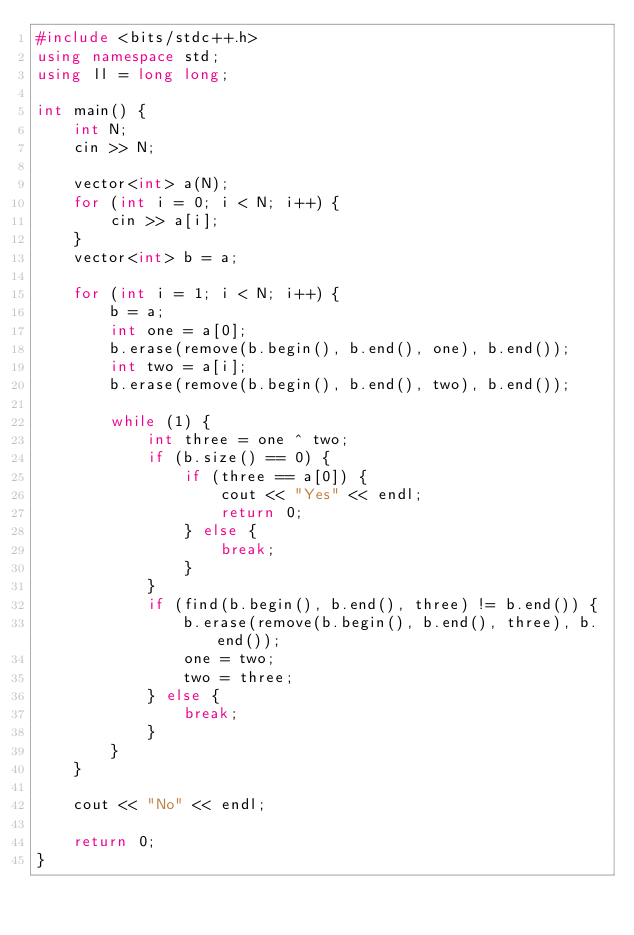<code> <loc_0><loc_0><loc_500><loc_500><_C++_>#include <bits/stdc++.h>
using namespace std;
using ll = long long;

int main() {
    int N;
    cin >> N;

    vector<int> a(N);
    for (int i = 0; i < N; i++) {
        cin >> a[i];
    }
    vector<int> b = a;

    for (int i = 1; i < N; i++) {
        b = a;
        int one = a[0];
        b.erase(remove(b.begin(), b.end(), one), b.end());
        int two = a[i];
        b.erase(remove(b.begin(), b.end(), two), b.end());

        while (1) {
            int three = one ^ two;
            if (b.size() == 0) {
                if (three == a[0]) {
                    cout << "Yes" << endl;
                    return 0;
                } else {
                    break;
                }
            }
            if (find(b.begin(), b.end(), three) != b.end()) {
                b.erase(remove(b.begin(), b.end(), three), b.end());
                one = two;
                two = three;
            } else {
                break;
            }
        }
    }

    cout << "No" << endl;

    return 0;
}
</code> 